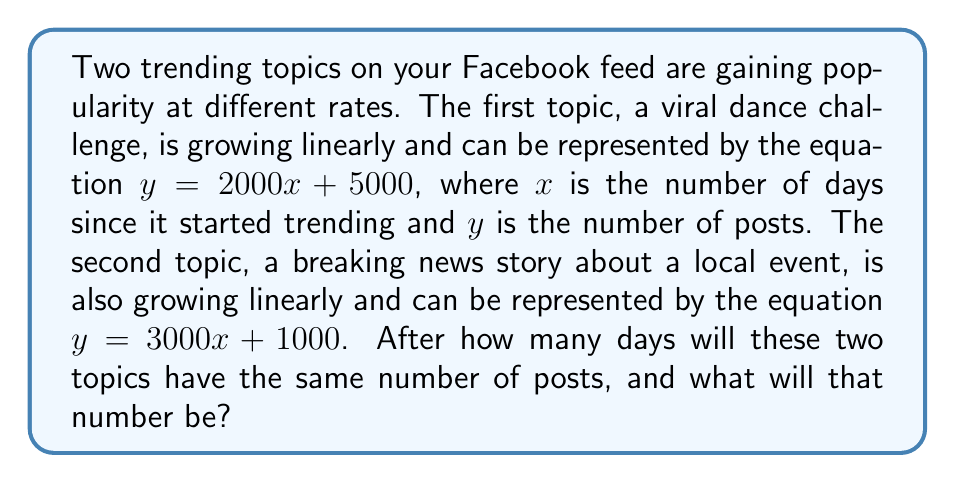Solve this math problem. To solve this problem, we need to find the intersection point of the two linear equations. This is where the number of posts for both topics will be equal.

Let's start by setting up our system of equations:
$$\begin{cases}
y = 2000x + 5000 \quad \text{(Dance Challenge)} \\
y = 3000x + 1000 \quad \text{(Local News)}
\end{cases}$$

Since we're looking for the point where these are equal, we can set them equal to each other:

$$2000x + 5000 = 3000x + 1000$$

Now, let's solve for $x$:

1) Subtract 2000x from both sides:
   $$5000 = 1000x + 1000$$

2) Subtract 1000 from both sides:
   $$4000 = 1000x$$

3) Divide both sides by 1000:
   $$4 = x$$

So, the topics will have the same number of posts after 4 days.

To find the number of posts at this point, we can plug $x = 4$ into either of our original equations. Let's use the first one:

$$y = 2000(4) + 5000 = 8000 + 5000 = 13000$$

Therefore, after 4 days, both topics will have 13,000 posts.
Answer: The two trending topics will have the same number of posts after 4 days, with 13,000 posts each. 